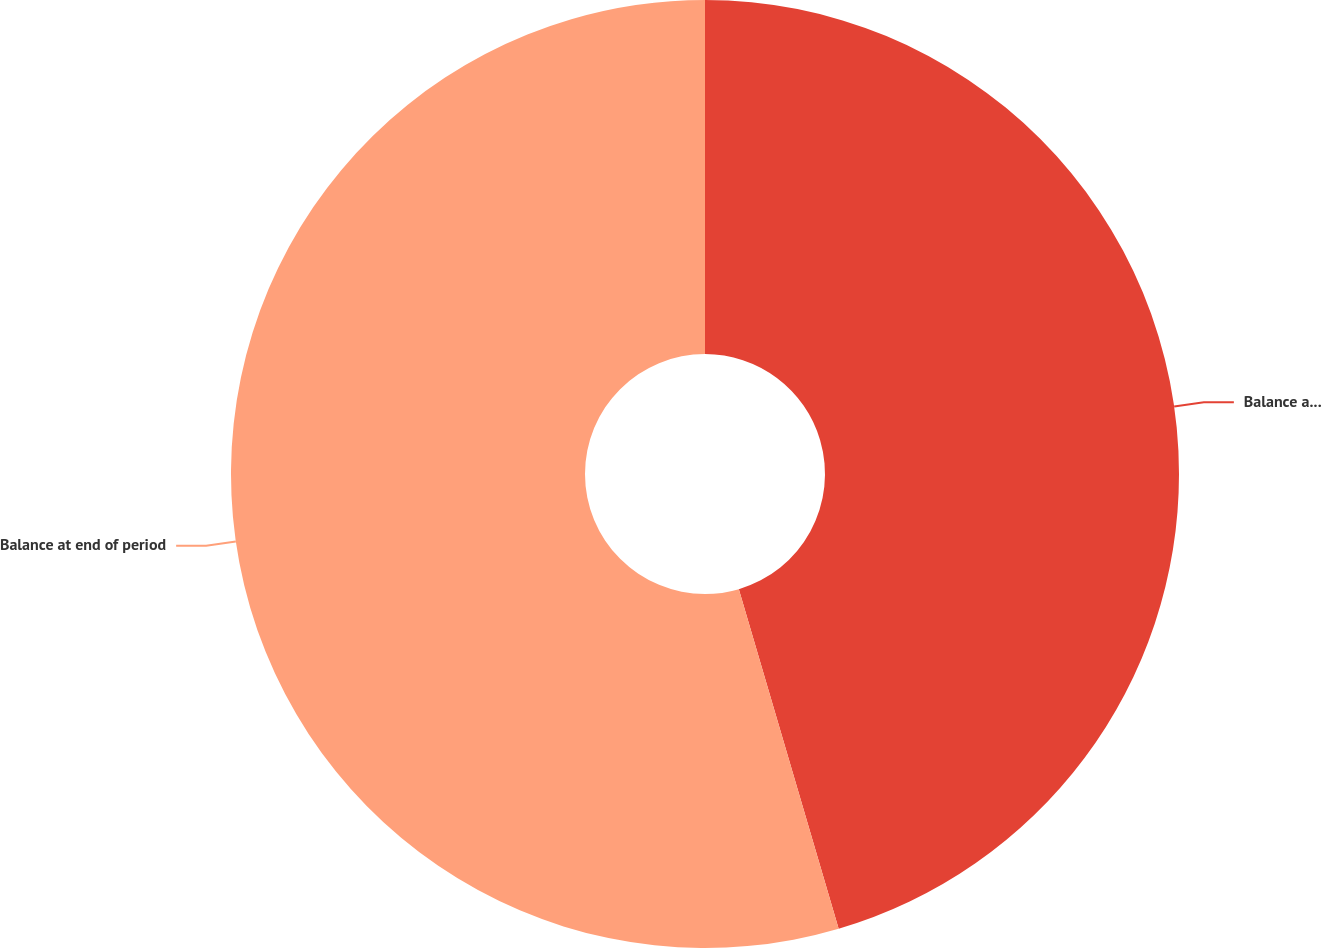Convert chart. <chart><loc_0><loc_0><loc_500><loc_500><pie_chart><fcel>Balance at beginning of period<fcel>Balance at end of period<nl><fcel>45.45%<fcel>54.55%<nl></chart> 